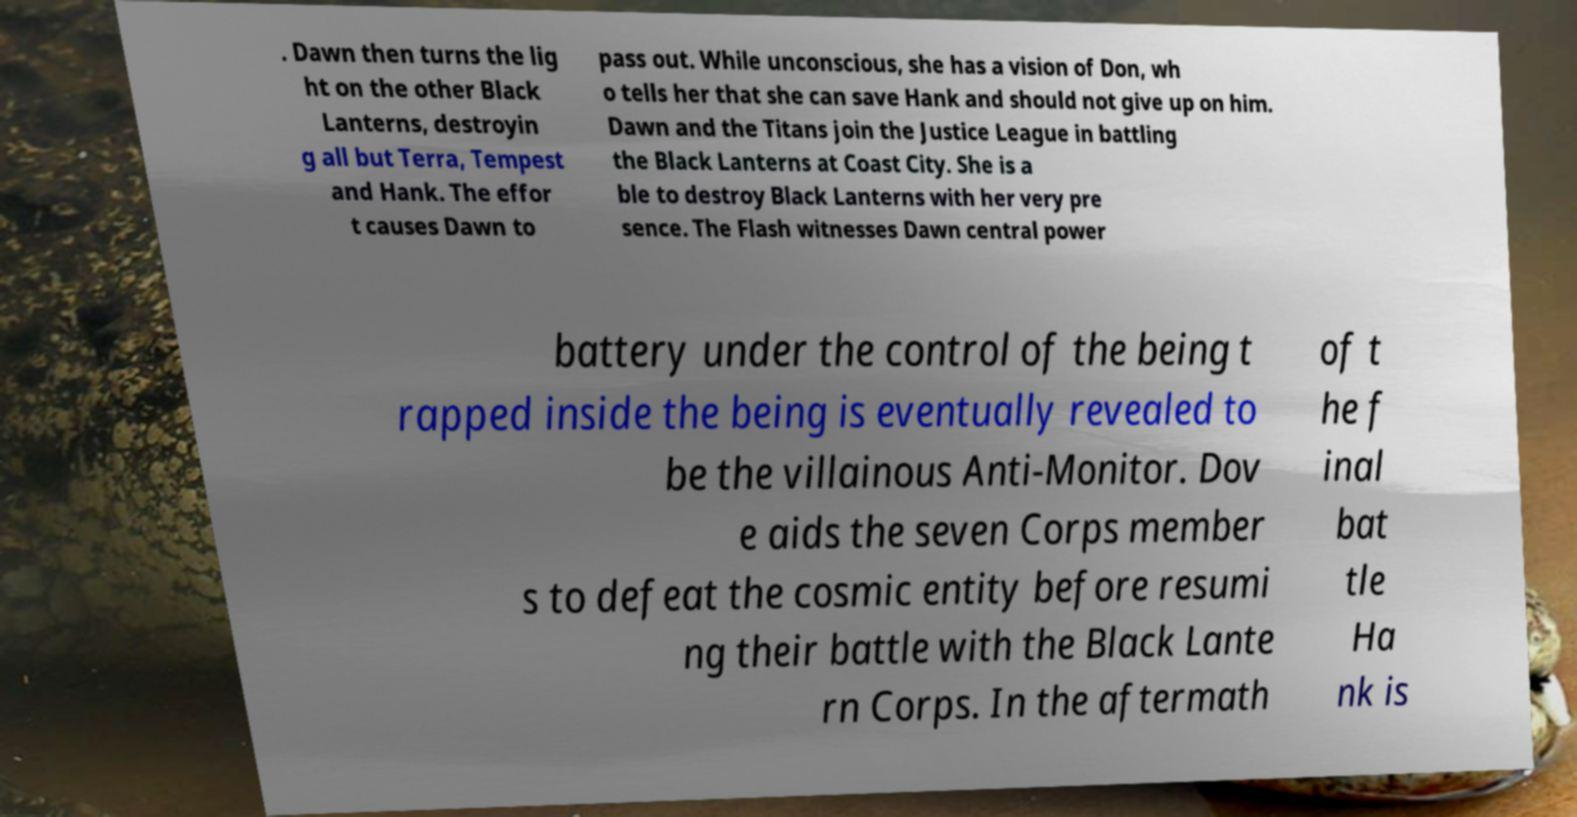Can you read and provide the text displayed in the image?This photo seems to have some interesting text. Can you extract and type it out for me? . Dawn then turns the lig ht on the other Black Lanterns, destroyin g all but Terra, Tempest and Hank. The effor t causes Dawn to pass out. While unconscious, she has a vision of Don, wh o tells her that she can save Hank and should not give up on him. Dawn and the Titans join the Justice League in battling the Black Lanterns at Coast City. She is a ble to destroy Black Lanterns with her very pre sence. The Flash witnesses Dawn central power battery under the control of the being t rapped inside the being is eventually revealed to be the villainous Anti-Monitor. Dov e aids the seven Corps member s to defeat the cosmic entity before resumi ng their battle with the Black Lante rn Corps. In the aftermath of t he f inal bat tle Ha nk is 